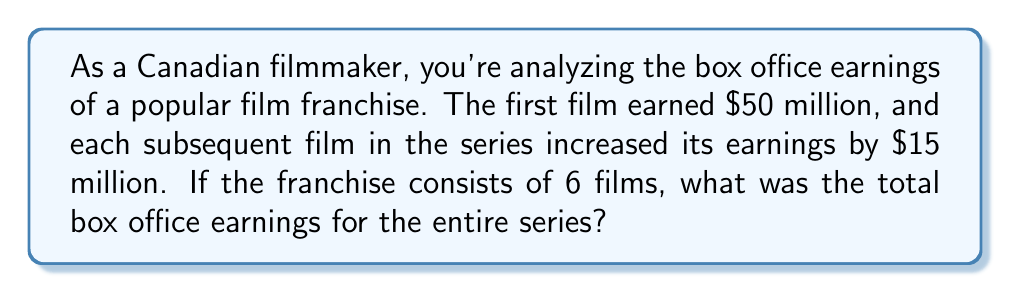Could you help me with this problem? Let's approach this step-by-step:

1) First, we need to identify the arithmetic sequence:
   - Initial term (a₁) = $50 million
   - Common difference (d) = $15 million
   - Number of terms (n) = 6

2) The arithmetic sequence formula is:
   $a_n = a_1 + (n-1)d$

3) Let's calculate the earnings for each film:
   Film 1: $a_1 = 50$ million
   Film 2: $a_2 = 50 + 15 = 65$ million
   Film 3: $a_3 = 50 + 2(15) = 80$ million
   Film 4: $a_4 = 50 + 3(15) = 95$ million
   Film 5: $a_5 = 50 + 4(15) = 110$ million
   Film 6: $a_6 = 50 + 5(15) = 125$ million

4) To find the total earnings, we need to sum these values. We can use the arithmetic sequence sum formula:

   $S_n = \frac{n}{2}(a_1 + a_n)$

   Where $a_n$ is the last term, which we calculated as $125 million.

5) Plugging in our values:

   $S_6 = \frac{6}{2}(50 + 125) = 3(175) = 525$

Therefore, the total box office earnings for the entire franchise is $525 million.
Answer: $525 million 